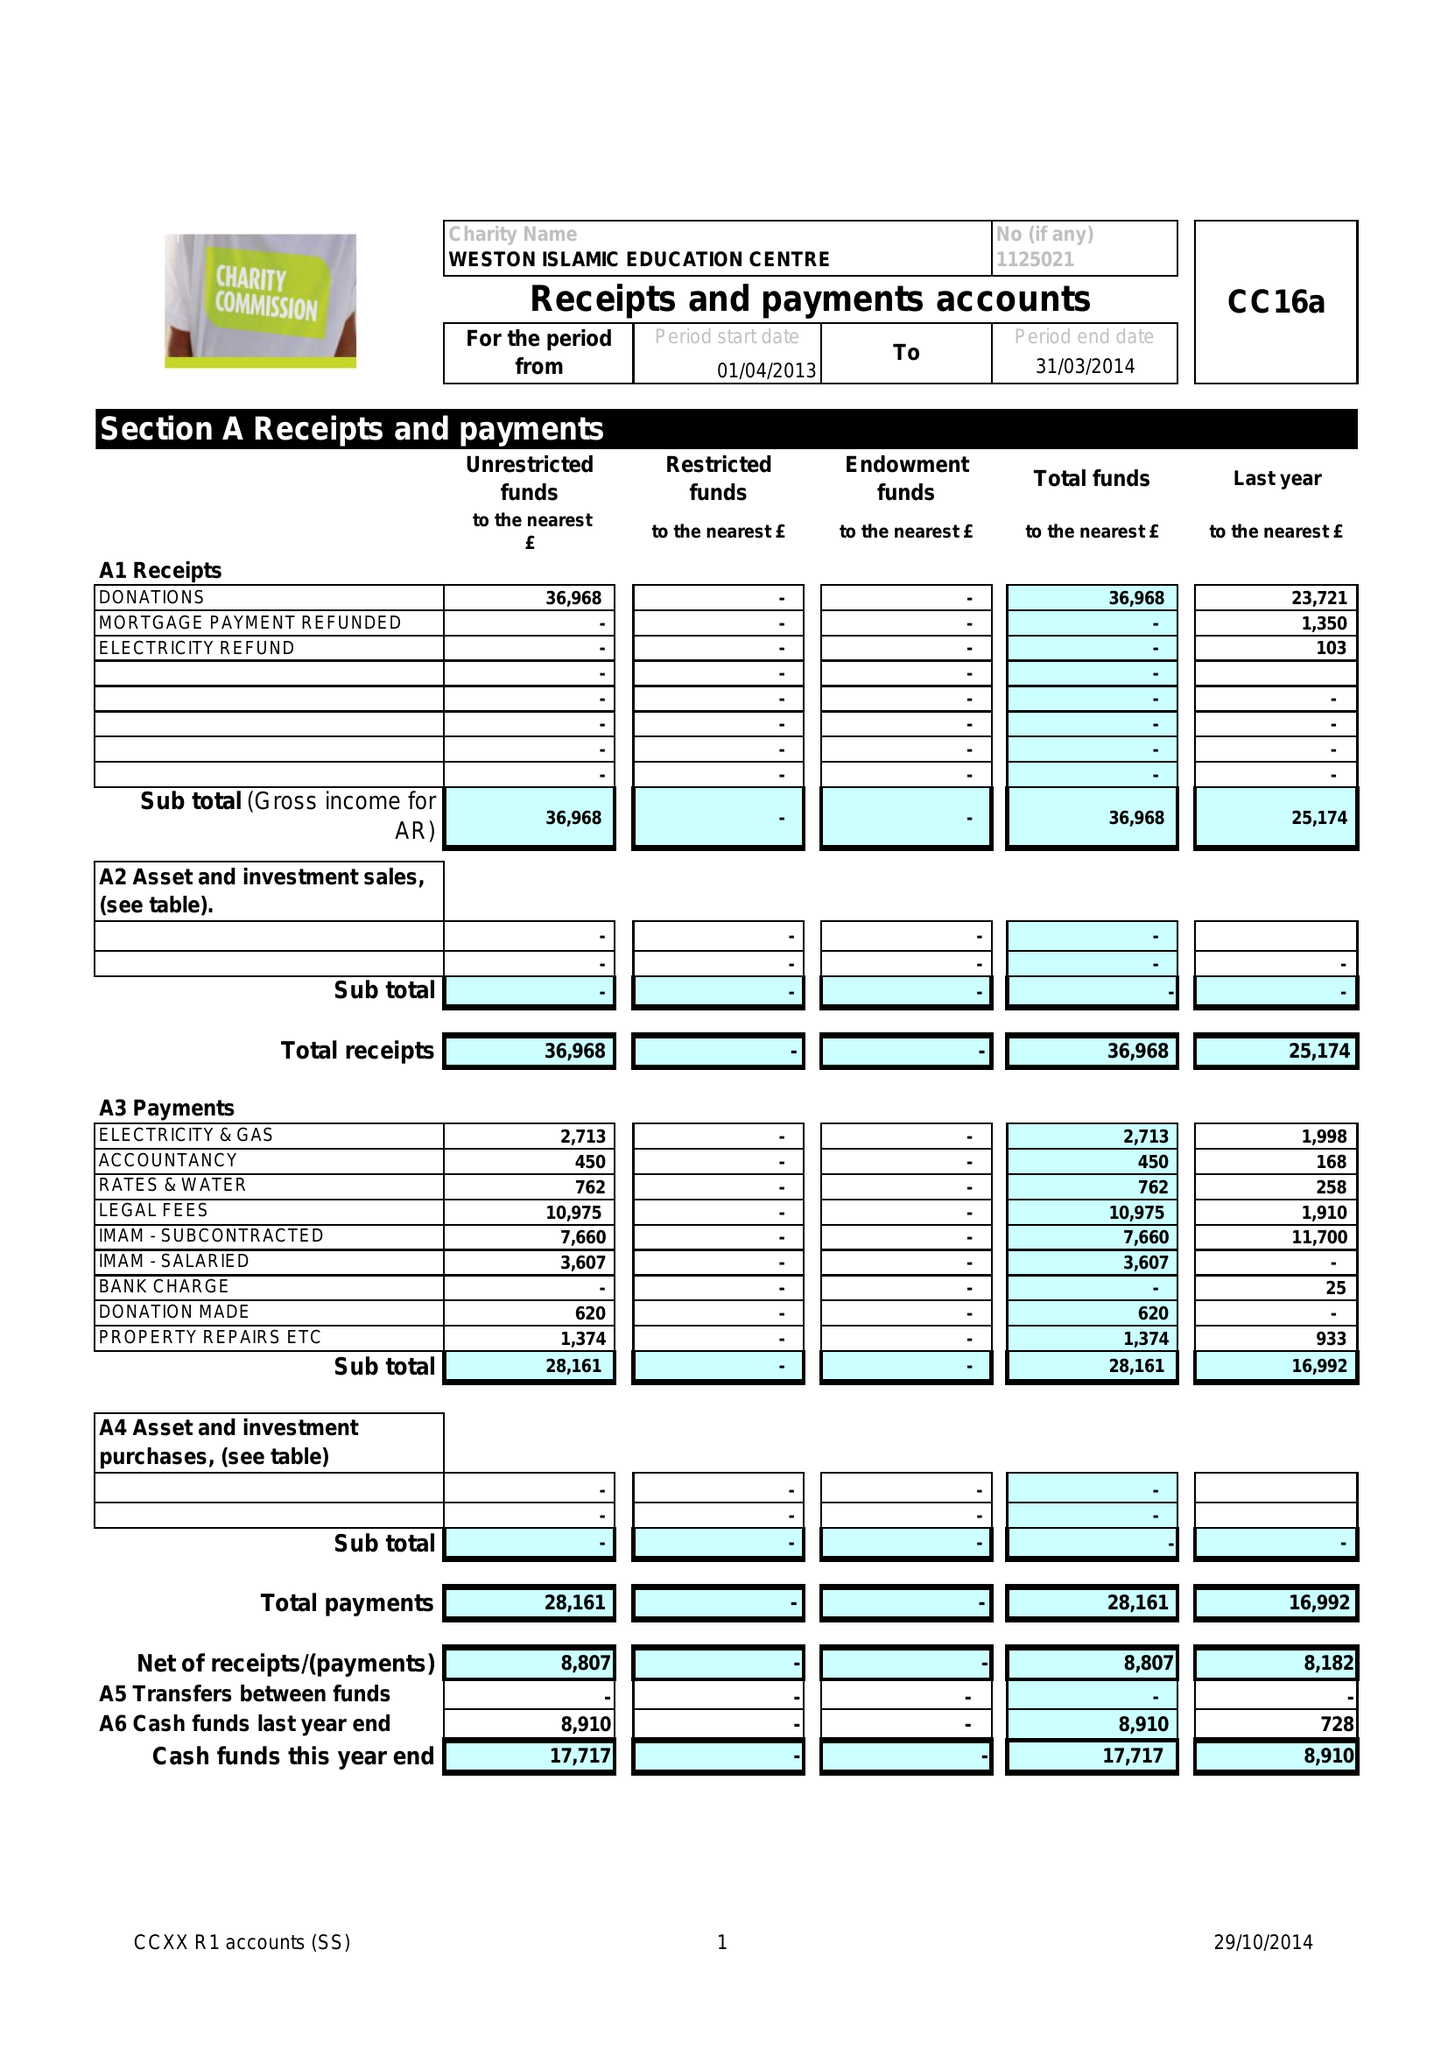What is the value for the address__street_line?
Answer the question using a single word or phrase. 66 PALMER STREET 